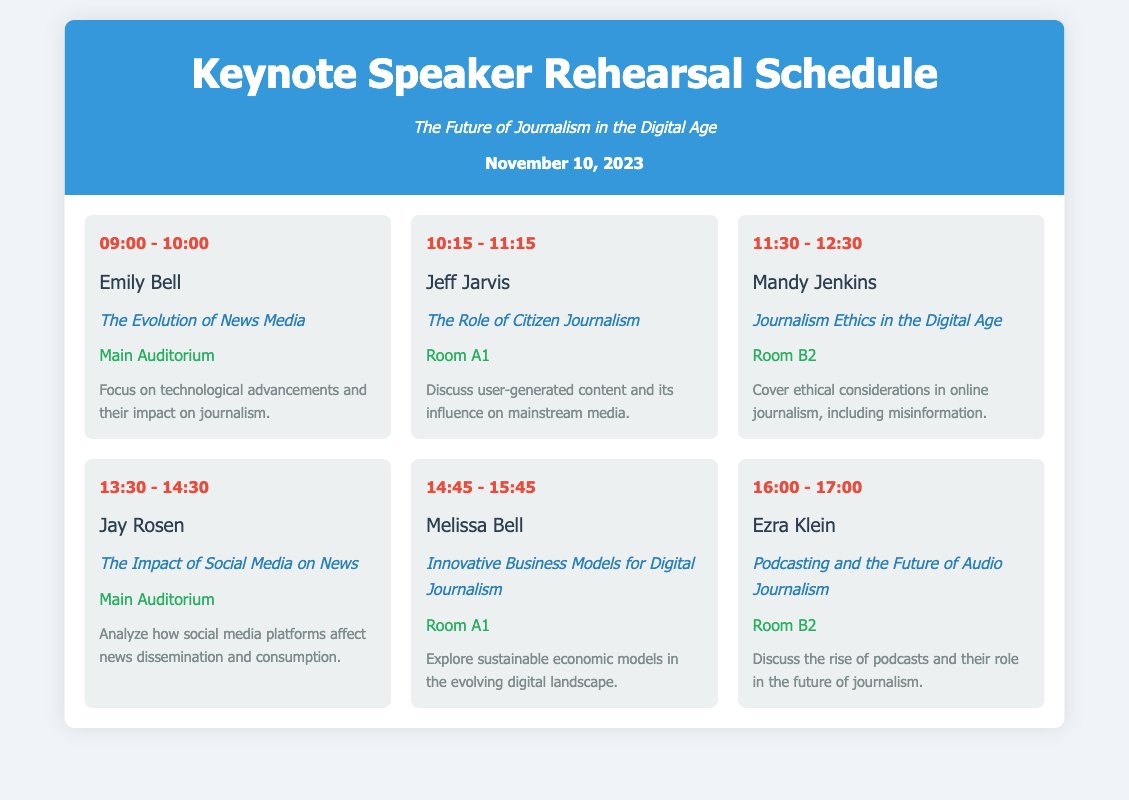What time does Emily Bell's rehearsal start? Emily Bell's rehearsal starts at 09:00 according to the schedule.
Answer: 09:00 What is the location for Jeff Jarvis's rehearsal? Jeff Jarvis's rehearsal is scheduled to take place in Room A1.
Answer: Room A1 How long is each keynote speaker's rehearsal? Each keynote speaker's rehearsal lasts for 1 hour as indicated by the time slots in the schedule.
Answer: 1 hour What is the topic of Mandy Jenkins's rehearsal? The topic of Mandy Jenkins's rehearsal is Journalism Ethics in the Digital Age as per the schedule details.
Answer: Journalism Ethics in the Digital Age Which speaker is discussing the impact of social media? The speaker discussing the impact of social media on news is Jay Rosen, as mentioned in the program.
Answer: Jay Rosen What is the last session of the day? The last session of the day features Ezra Klein discussing Podcasting and the Future of Audio Journalism.
Answer: Podcasting and the Future of Audio Journalism How many speakers are featured in the schedule? There are six speakers featured in the rehearsal schedule, as listed in the document.
Answer: Six What is the date of the symposium? The date of the symposium is specified as November 10, 2023.
Answer: November 10, 2023 Where will Melissa Bell's session be held? Melissa Bell's session will be held in Room A1, as stated in the schedule.
Answer: Room A1 